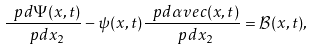<formula> <loc_0><loc_0><loc_500><loc_500>\frac { \ p d \Psi ( x , t ) } { \ p d x _ { 2 } } - \psi ( x , t ) \frac { \ p d \alpha v e c ( x , t ) } { \ p d x _ { 2 } } = \mathcal { B } ( x , t ) ,</formula> 